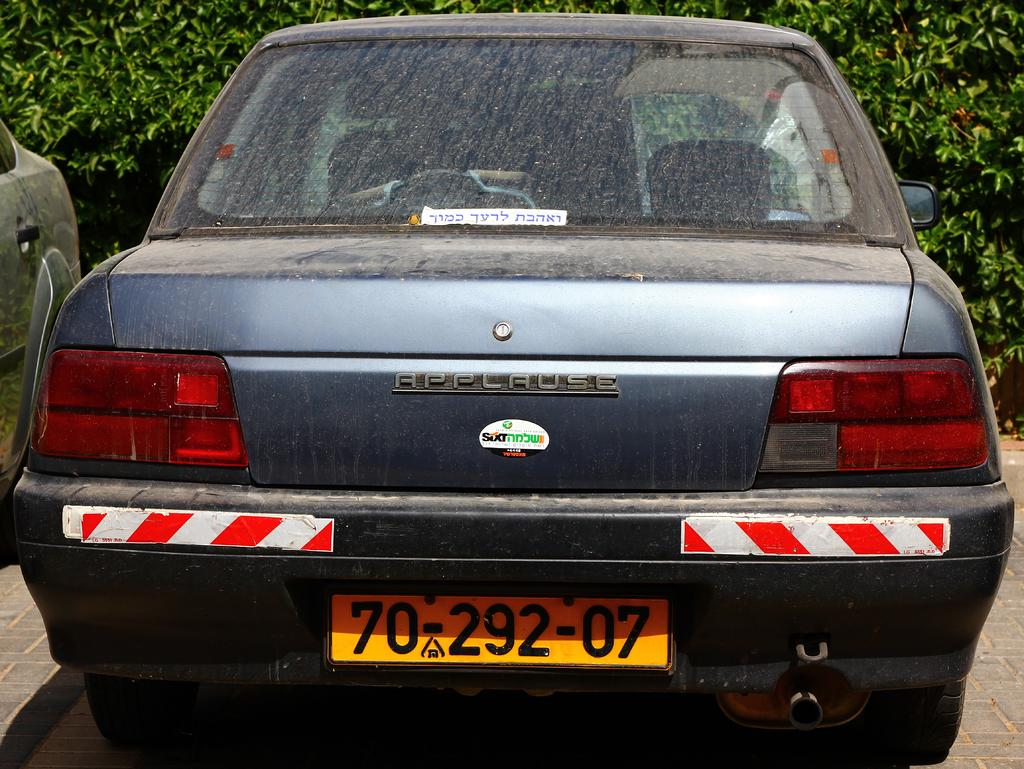Provide a one-sentence caption for the provided image. The back side of a dirty Applause automobile. 